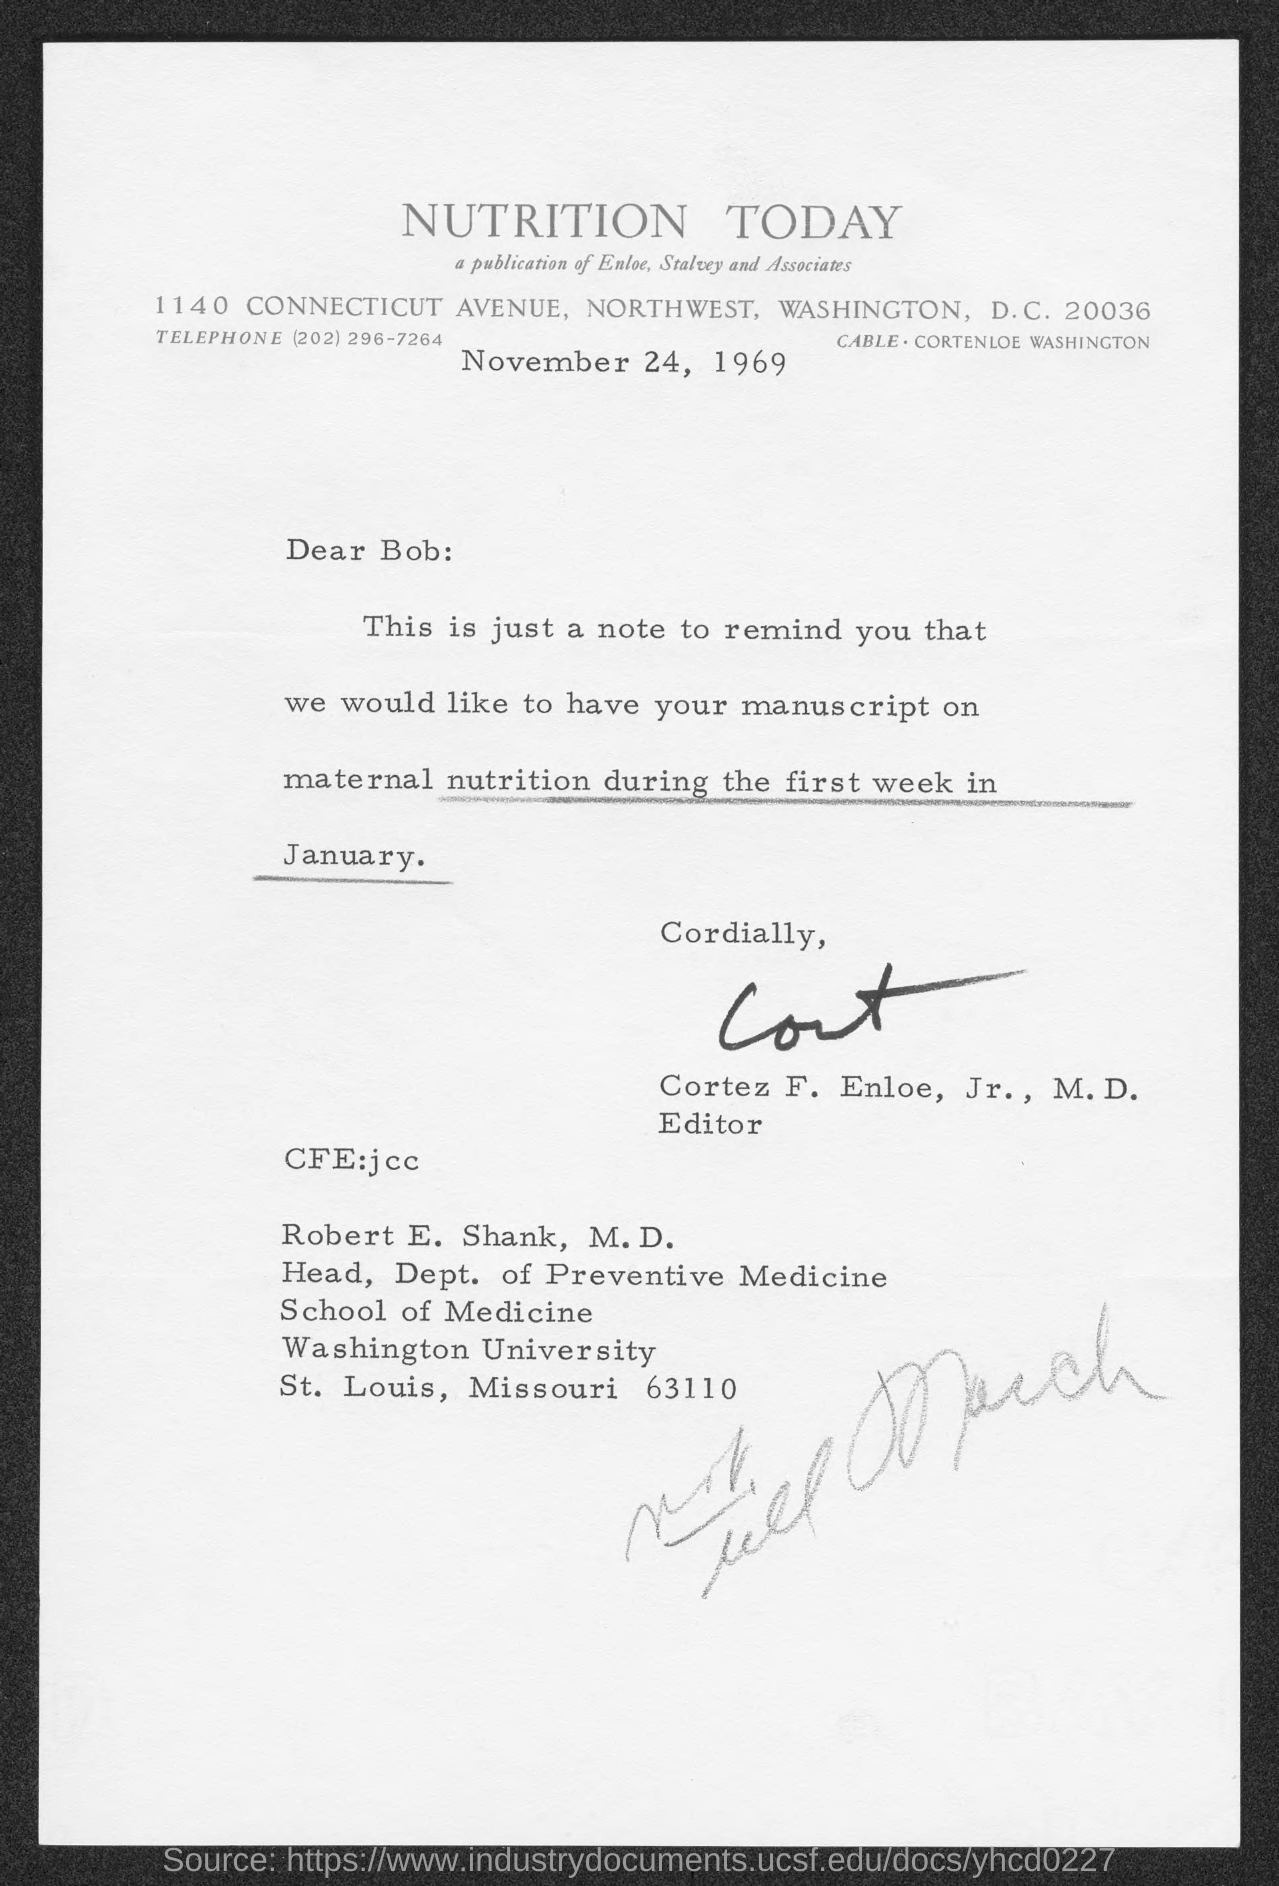Outline some significant characteristics in this image. The date mentioned in this letter is November 24, 1969. 